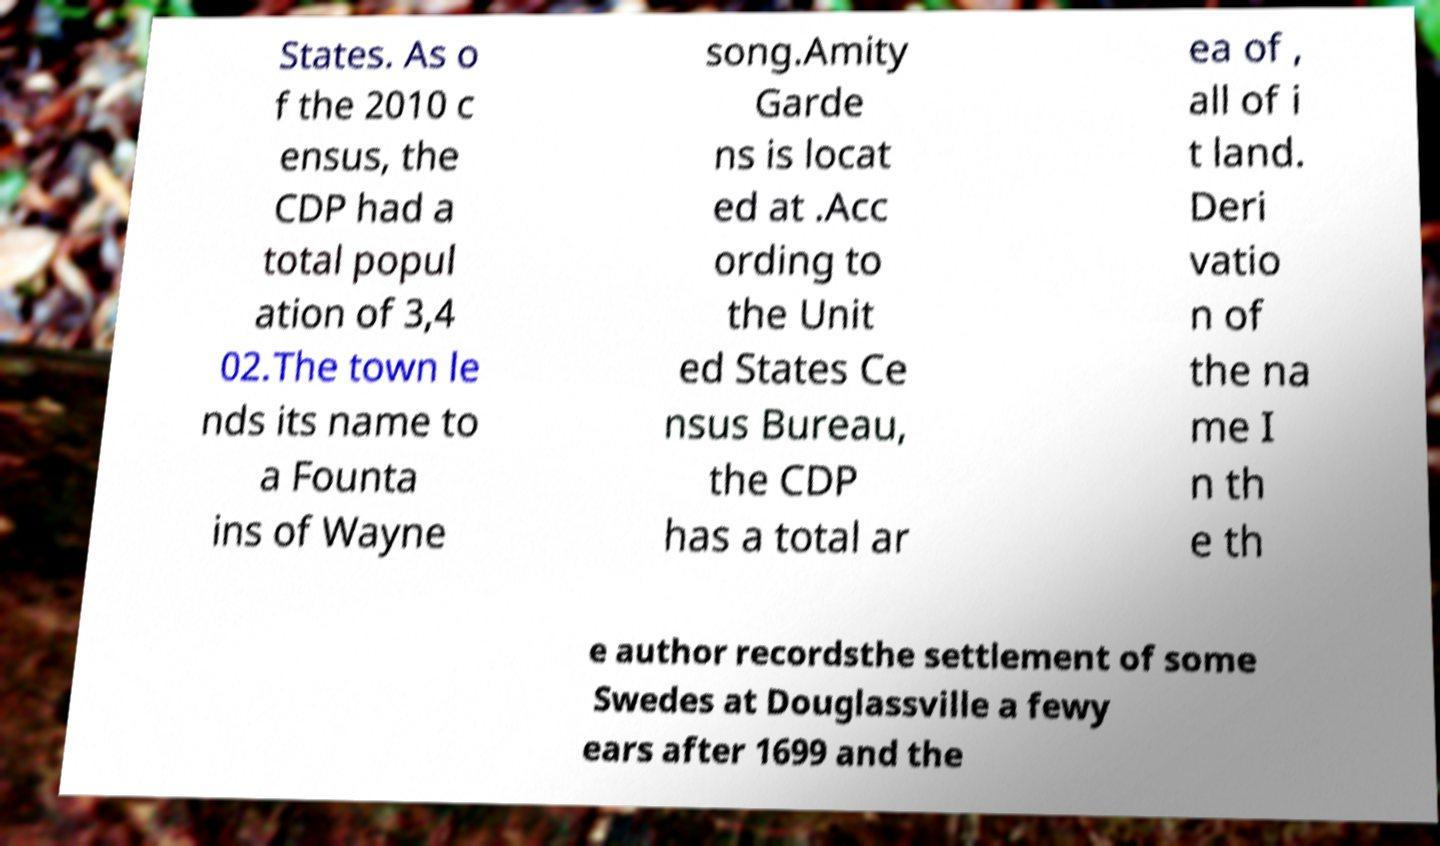Please read and relay the text visible in this image. What does it say? States. As o f the 2010 c ensus, the CDP had a total popul ation of 3,4 02.The town le nds its name to a Founta ins of Wayne song.Amity Garde ns is locat ed at .Acc ording to the Unit ed States Ce nsus Bureau, the CDP has a total ar ea of , all of i t land. Deri vatio n of the na me I n th e th e author recordsthe settlement of some Swedes at Douglassville a fewy ears after 1699 and the 